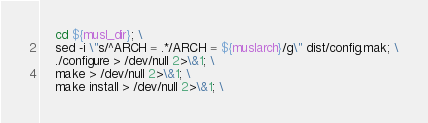<code> <loc_0><loc_0><loc_500><loc_500><_Bash_>	cd ${musl_dir}; \
	sed -i \"s/^ARCH = .*/ARCH = ${muslarch}/g\" dist/config.mak; \
	./configure > /dev/null 2>\&1; \
	make > /dev/null 2>\&1; \
	make install > /dev/null 2>\&1; \</code> 